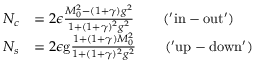Convert formula to latex. <formula><loc_0><loc_0><loc_500><loc_500>\begin{array} { r l } { N _ { c } } & { = 2 \epsilon \frac { M _ { 0 } ^ { 2 } - ( 1 + \gamma ) g ^ { 2 } } { 1 + ( 1 + \gamma ) ^ { 2 } g ^ { 2 } } \quad ( ^ { \prime } i n - o u t ^ { \prime } ) } \\ { N _ { s } } & { = 2 \epsilon g \frac { 1 + ( 1 + \gamma ) M _ { 0 } ^ { 2 } } { 1 + ( 1 + \gamma ) ^ { 2 } g ^ { 2 } } \quad ( ^ { \prime } u p - d o w n ^ { \prime } ) } \end{array}</formula> 